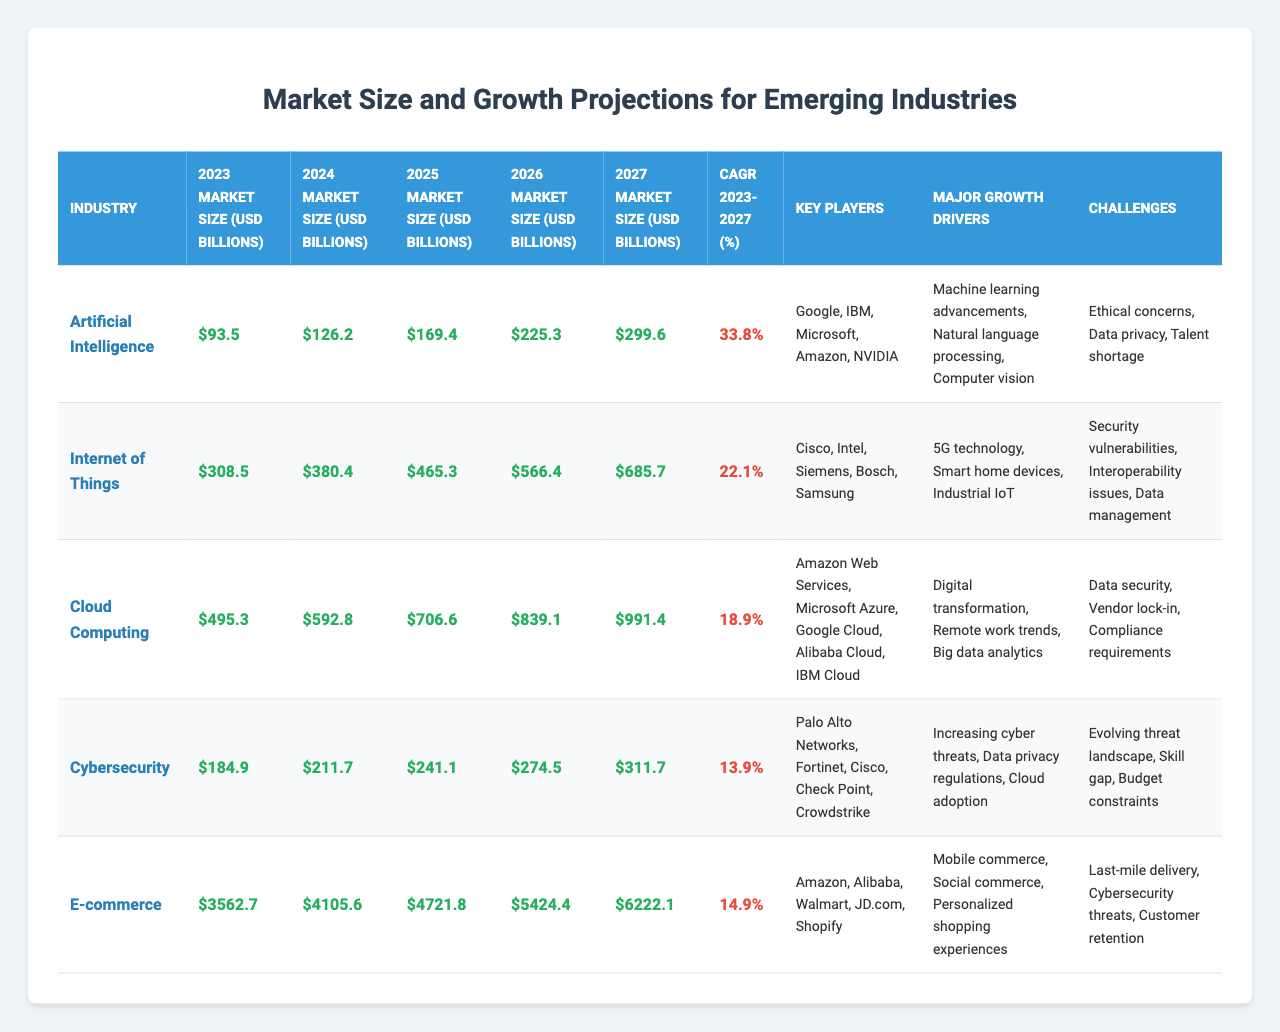What's the market size of Cybersecurity in 2027? The table shows that the market size for Cybersecurity in 2027 is listed under the corresponding column, which is 311.7 billion USD.
Answer: 311.7 billion USD Which industry has the highest CAGR from 2023 to 2027? By examining the CAGR percentages in the table, Artificial Intelligence has the highest CAGR at 33.8%, compared to other industries.
Answer: Artificial Intelligence What will be the market size of E-commerce in 2025? The market size for E-commerce in 2025 is listed in the table and is 4721.8 billion USD.
Answer: 4721.8 billion USD What is the total projected market size for Artificial Intelligence from 2023 to 2027? To find the total projected market size for Artificial Intelligence, sum the values across each year: 93.5 + 126.2 + 169.4 + 225.3 + 299.6 = 1114.0 billion USD.
Answer: 1114.0 billion USD What challenges does the E-commerce industry face according to the table? The challenges regarding E-commerce are listed in the table as Last-mile delivery, Cybersecurity threats, and Customer retention.
Answer: Last-mile delivery, Cybersecurity threats, Customer retention How much larger is the 2027 market size of the Internet of Things compared to 2023? Subtract the 2023 market size from the 2027 market size for the Internet of Things: 685.7 - 308.5 = 377.2 billion USD larger.
Answer: 377.2 billion USD Are there any industries expected to grow at a CAGR higher than 20%? By looking at the CAGR values in the table, yes, Artificial Intelligence and Internet of Things have CAGRs greater than 20%.
Answer: Yes What is the average market size for Cloud Computing from 2023 to 2027? To find the average, sum the values for Cloud Computing from 2023 to 2027 (495.3 + 592.8 + 706.6 + 839.1 + 991.4) and divide by 5: (495.3 + 592.8 + 706.6 + 839.1 + 991.4)/5 = 725.0 billion USD.
Answer: 725.0 billion USD What is a major growth driver for Cybersecurity? The major growth drivers for Cybersecurity are stated in the table as Increasing cyber threats, Data privacy regulations, and Cloud adoption.
Answer: Increasing cyber threats, Data privacy regulations, Cloud adoption Which industry is projected to have the lowest market size in 2024? The market size for each industry in 2024 is compared; Cybersecurity has the lowest market size at 211.7 billion USD.
Answer: Cybersecurity 